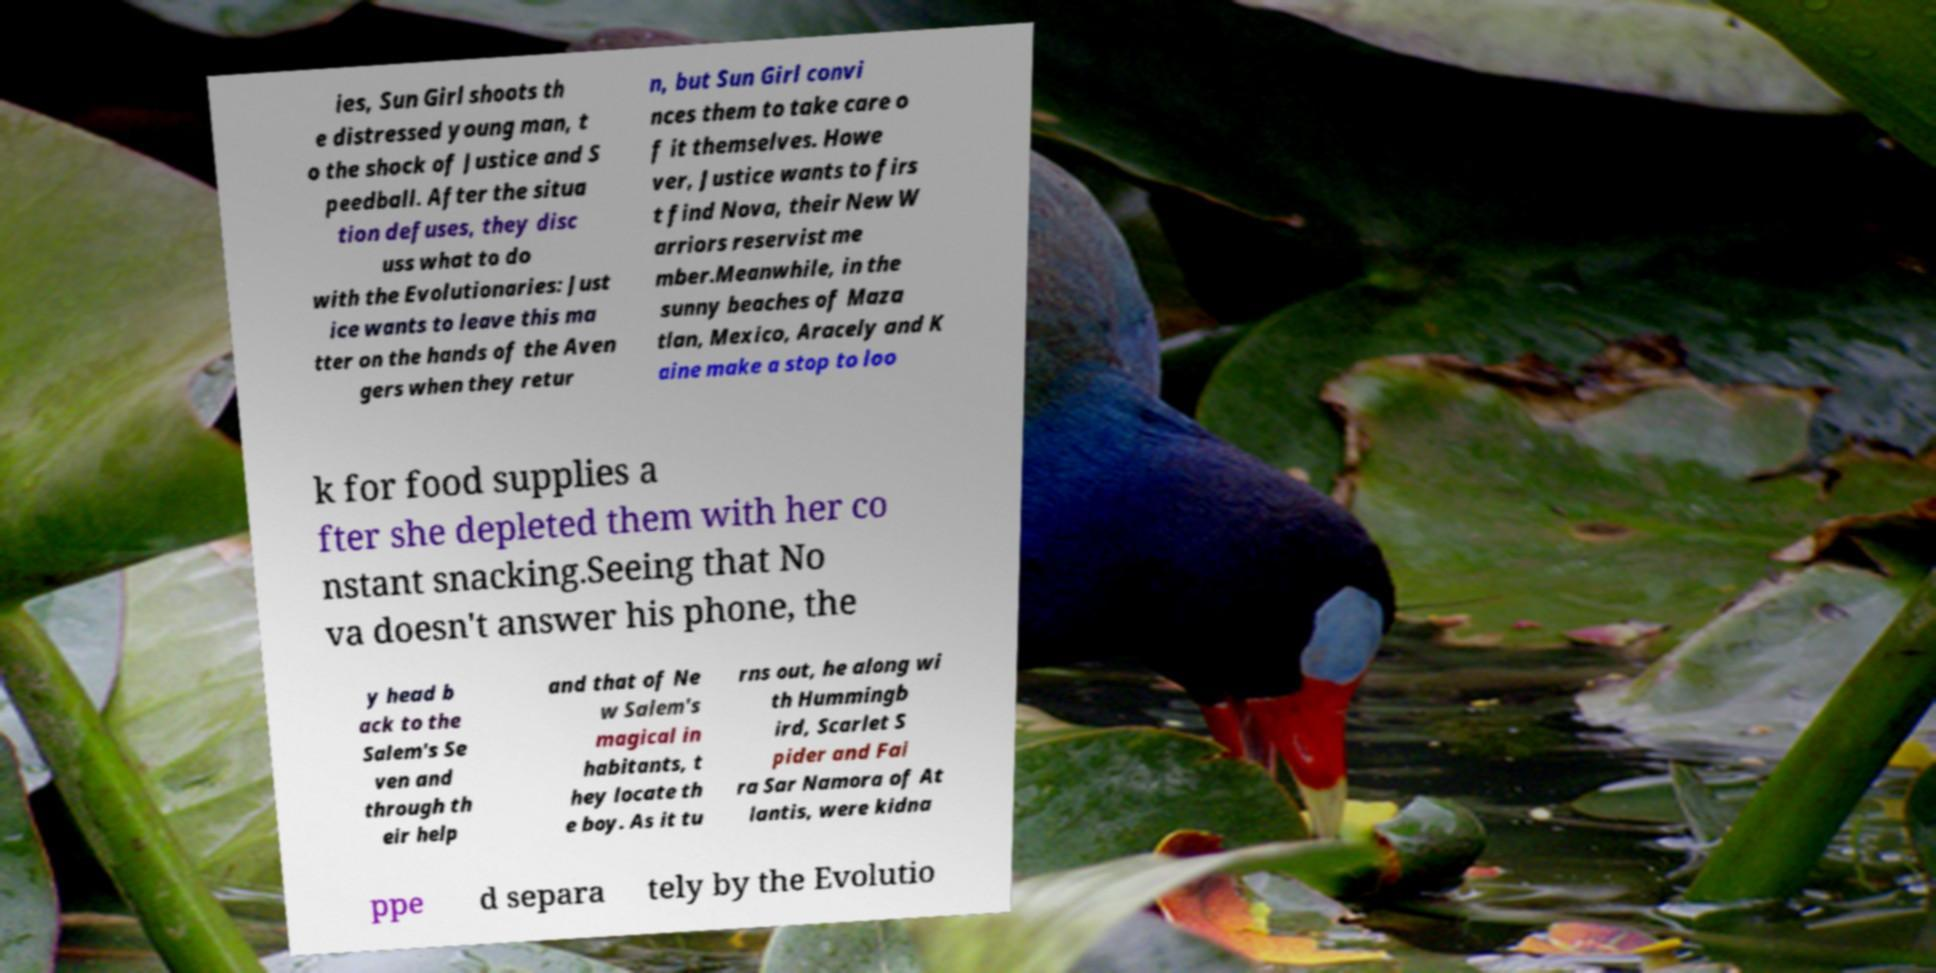There's text embedded in this image that I need extracted. Can you transcribe it verbatim? ies, Sun Girl shoots th e distressed young man, t o the shock of Justice and S peedball. After the situa tion defuses, they disc uss what to do with the Evolutionaries: Just ice wants to leave this ma tter on the hands of the Aven gers when they retur n, but Sun Girl convi nces them to take care o f it themselves. Howe ver, Justice wants to firs t find Nova, their New W arriors reservist me mber.Meanwhile, in the sunny beaches of Maza tlan, Mexico, Aracely and K aine make a stop to loo k for food supplies a fter she depleted them with her co nstant snacking.Seeing that No va doesn't answer his phone, the y head b ack to the Salem's Se ven and through th eir help and that of Ne w Salem's magical in habitants, t hey locate th e boy. As it tu rns out, he along wi th Hummingb ird, Scarlet S pider and Fai ra Sar Namora of At lantis, were kidna ppe d separa tely by the Evolutio 